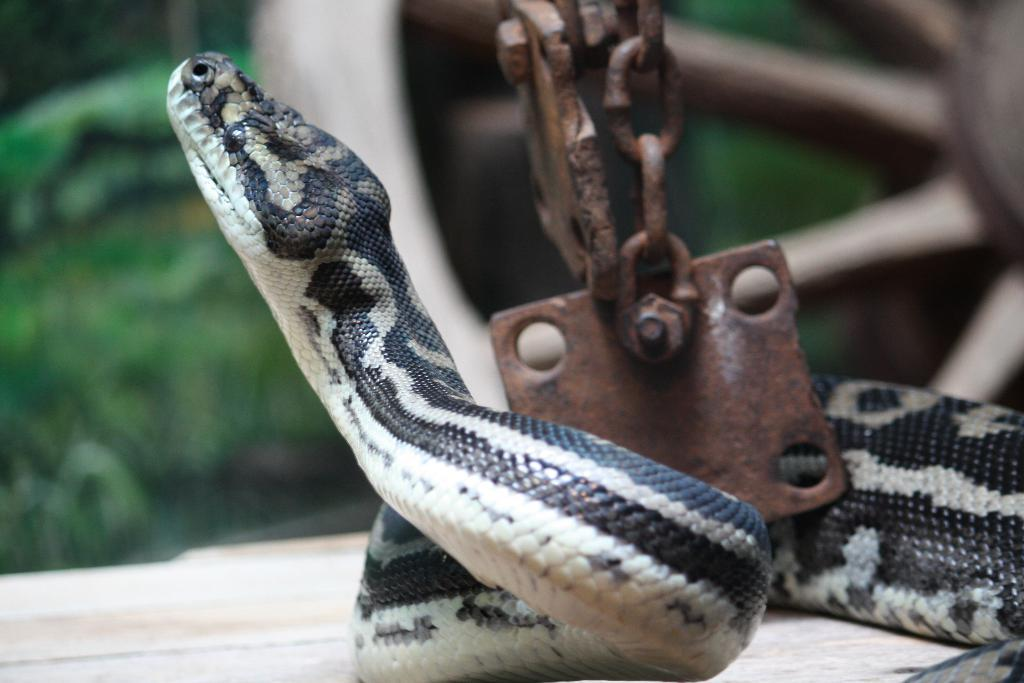What type of animal is in the image? There is a snake in the image. What other object can be seen in the image? There is a chain and a wheel in the image. Can you describe the background of the image? The background of the image is blurred. What type of seed is being planted by the train in the image? There is no train or seed present in the image; it features a snake, a chain, and a wheel. What type of battle is depicted in the image? There is no battle depicted in the image; it features a snake, a chain, and a wheel. 